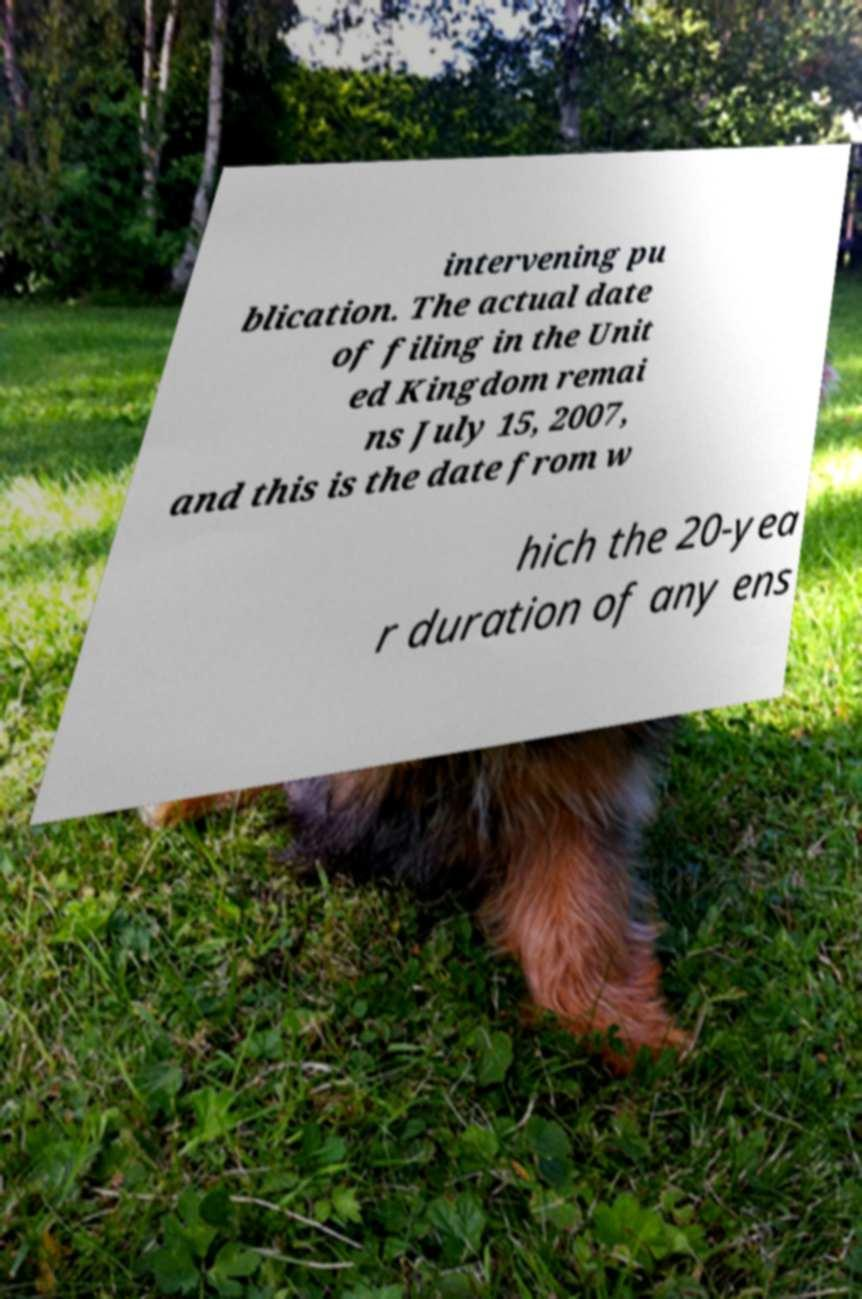What messages or text are displayed in this image? I need them in a readable, typed format. intervening pu blication. The actual date of filing in the Unit ed Kingdom remai ns July 15, 2007, and this is the date from w hich the 20-yea r duration of any ens 